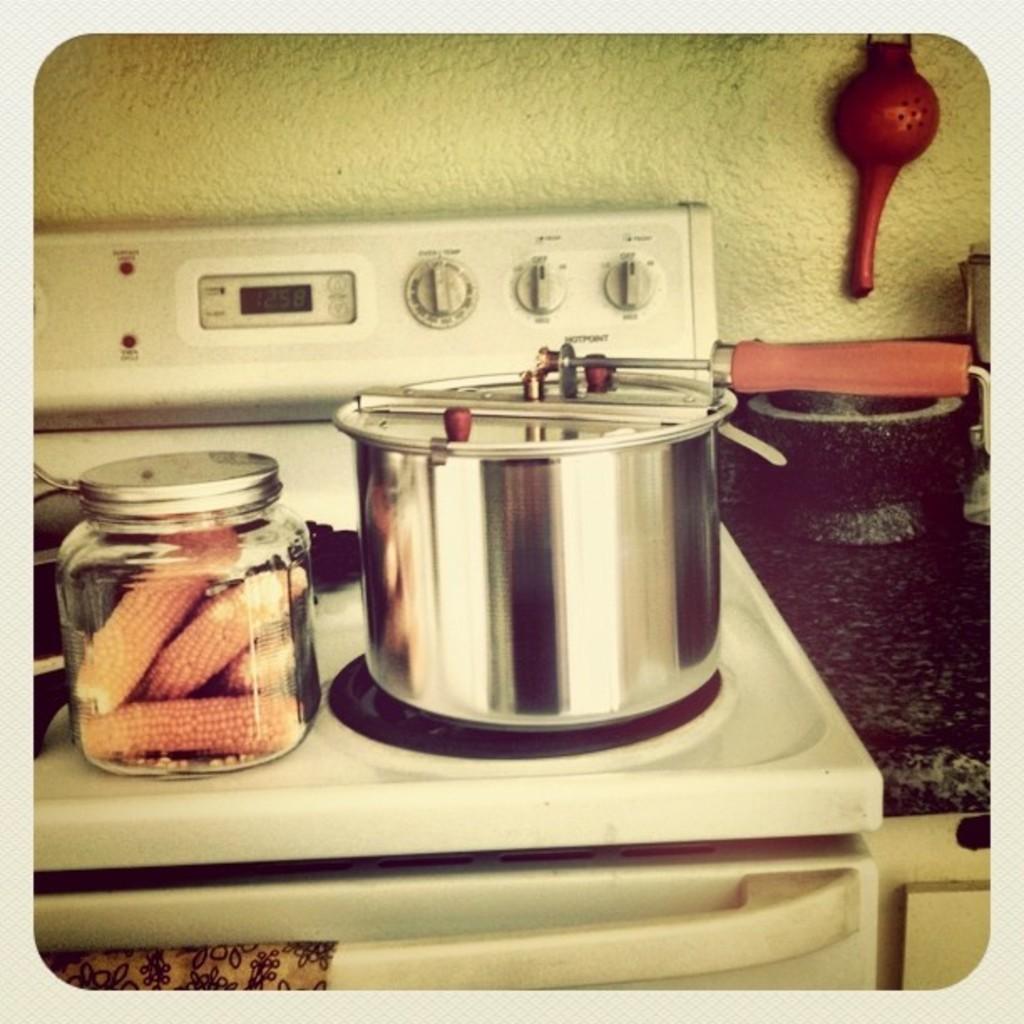What time is listed on the stove clock?
Provide a short and direct response. 12:58. 